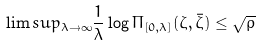Convert formula to latex. <formula><loc_0><loc_0><loc_500><loc_500>\lim s u p _ { \lambda \to \infty } \frac { 1 } { \lambda } \log \Pi _ { [ 0 , \lambda ] } ( \zeta , \bar { \zeta } ) \leq \sqrt { \rho }</formula> 